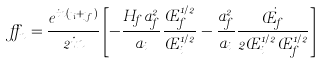<formula> <loc_0><loc_0><loc_500><loc_500>\alpha _ { n } = \frac { e ^ { i n ( \eta _ { i } + \eta _ { f } ) } } { 2 i n } \left [ - \frac { H _ { f } a _ { f } ^ { 2 } } { a _ { i } } \frac { \phi _ { f } ^ { 1 / 2 } } { \phi _ { i } ^ { 1 / 2 } } - \frac { a _ { f } ^ { 2 } } { a _ { i } } \frac { \dot { \phi _ { f } } } { 2 \phi _ { i } ^ { 1 / 2 } \phi _ { f } ^ { 1 / 2 } } \right ]</formula> 